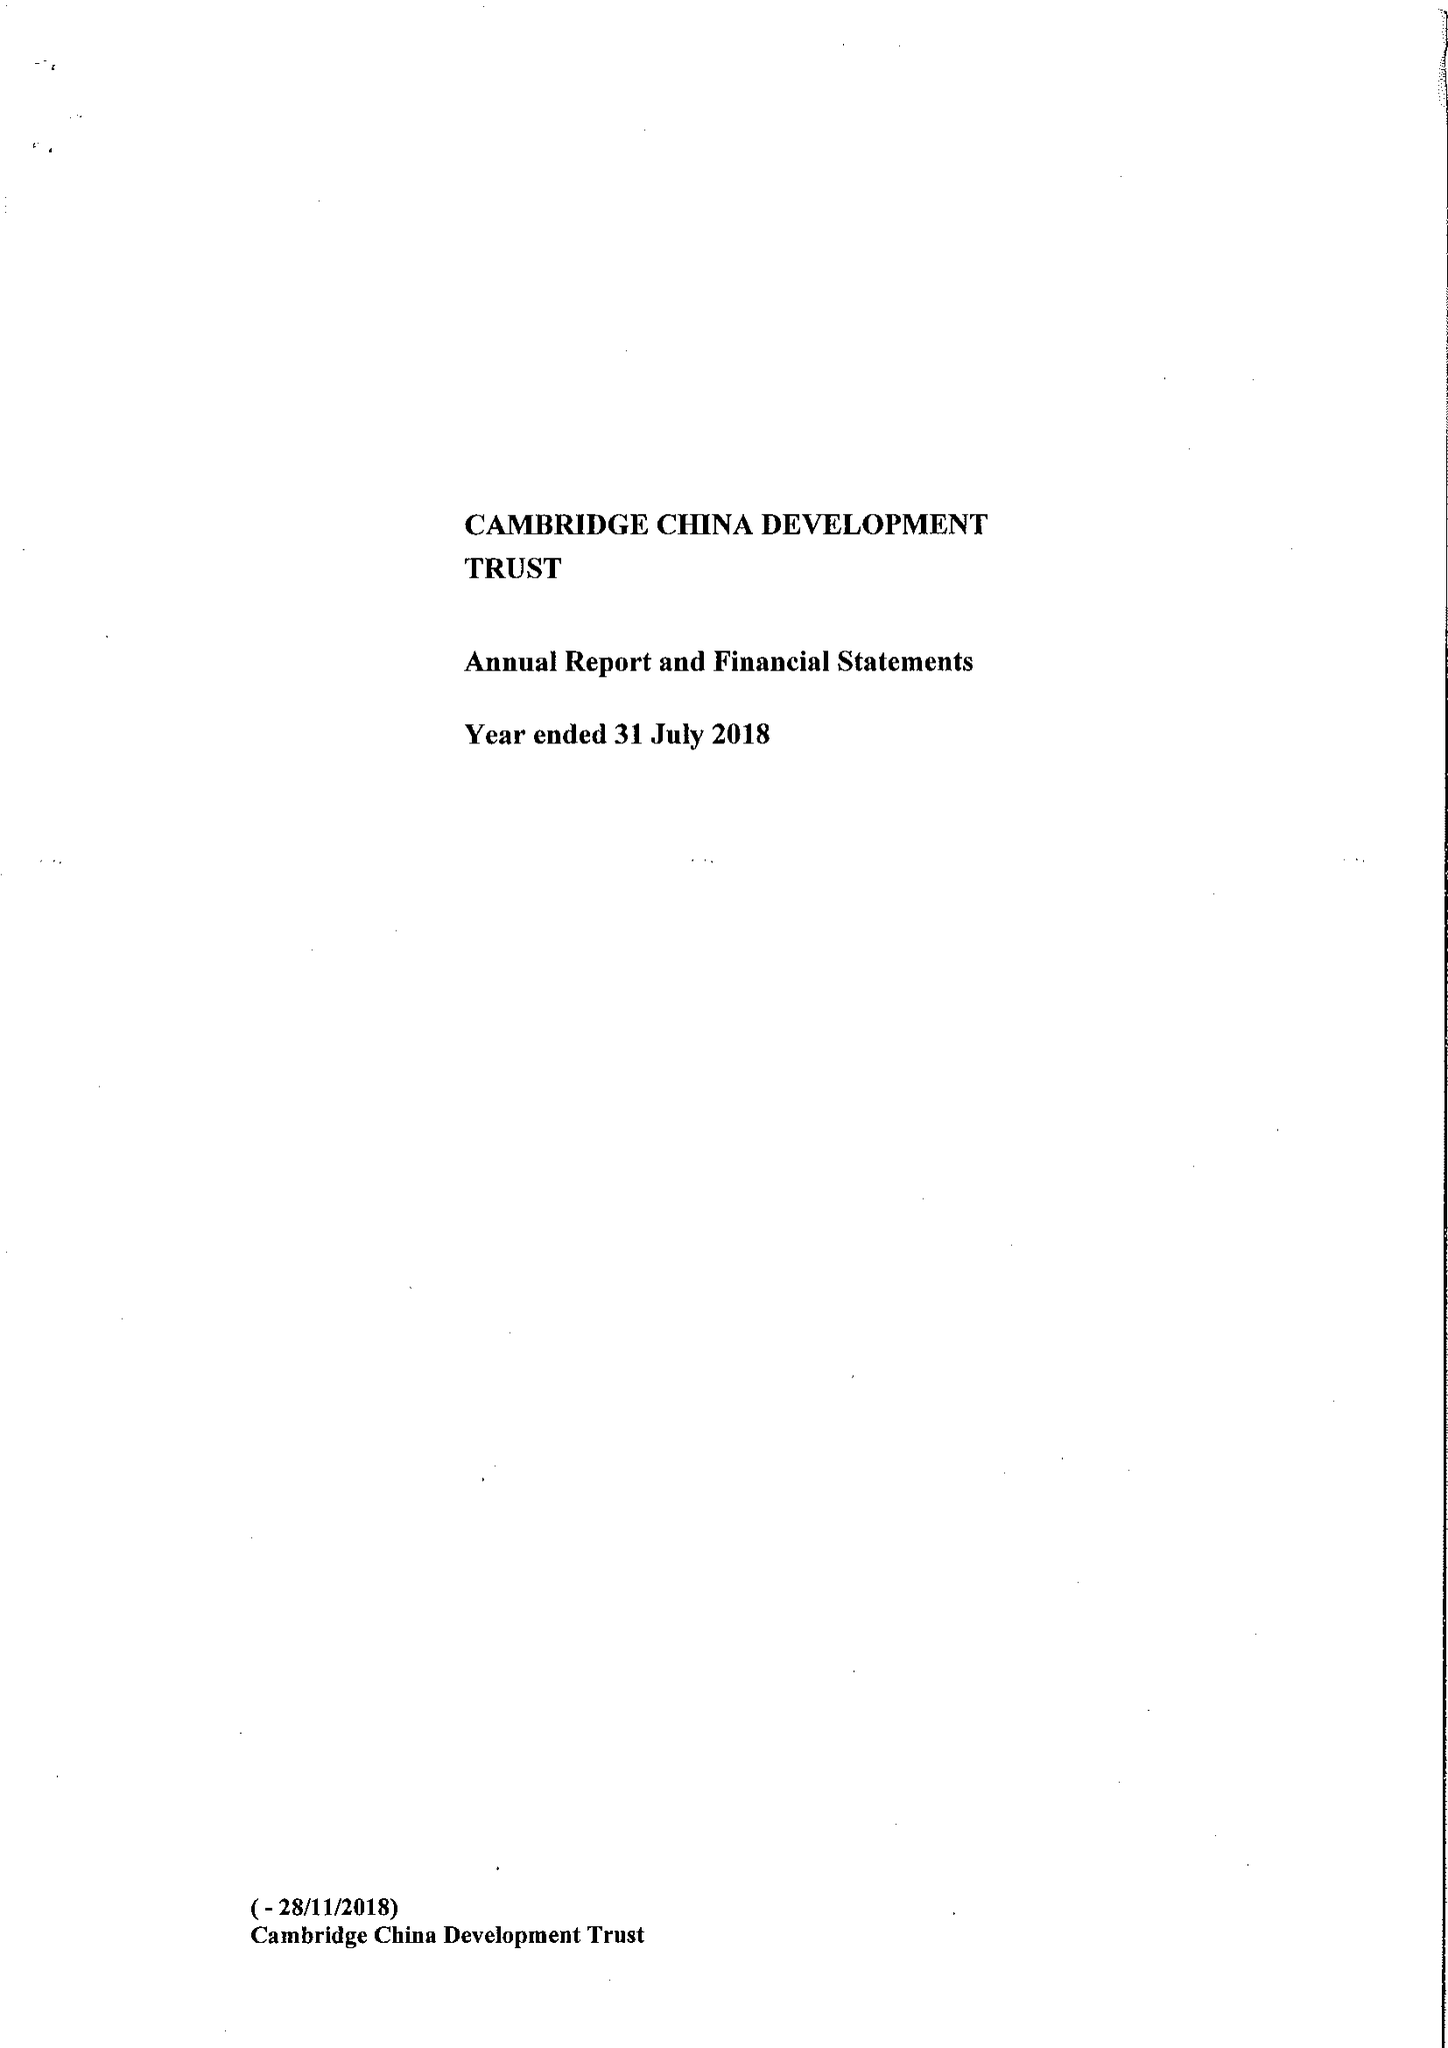What is the value for the address__post_town?
Answer the question using a single word or phrase. CAMBRIDGE 